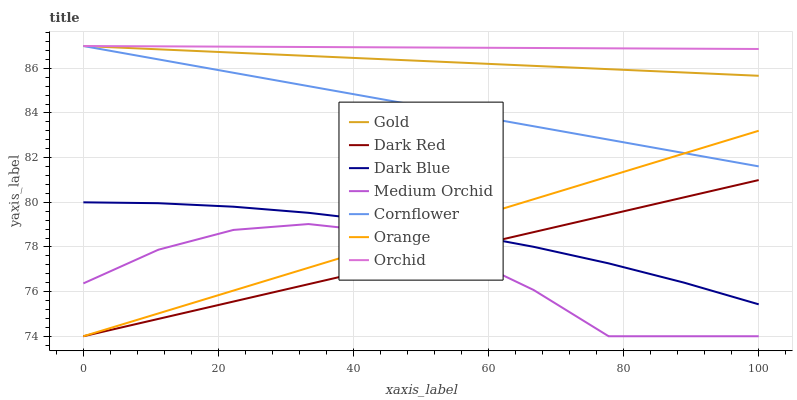Does Medium Orchid have the minimum area under the curve?
Answer yes or no. Yes. Does Orchid have the maximum area under the curve?
Answer yes or no. Yes. Does Gold have the minimum area under the curve?
Answer yes or no. No. Does Gold have the maximum area under the curve?
Answer yes or no. No. Is Orange the smoothest?
Answer yes or no. Yes. Is Medium Orchid the roughest?
Answer yes or no. Yes. Is Gold the smoothest?
Answer yes or no. No. Is Gold the roughest?
Answer yes or no. No. Does Dark Red have the lowest value?
Answer yes or no. Yes. Does Gold have the lowest value?
Answer yes or no. No. Does Orchid have the highest value?
Answer yes or no. Yes. Does Dark Red have the highest value?
Answer yes or no. No. Is Orange less than Gold?
Answer yes or no. Yes. Is Gold greater than Orange?
Answer yes or no. Yes. Does Orange intersect Cornflower?
Answer yes or no. Yes. Is Orange less than Cornflower?
Answer yes or no. No. Is Orange greater than Cornflower?
Answer yes or no. No. Does Orange intersect Gold?
Answer yes or no. No. 